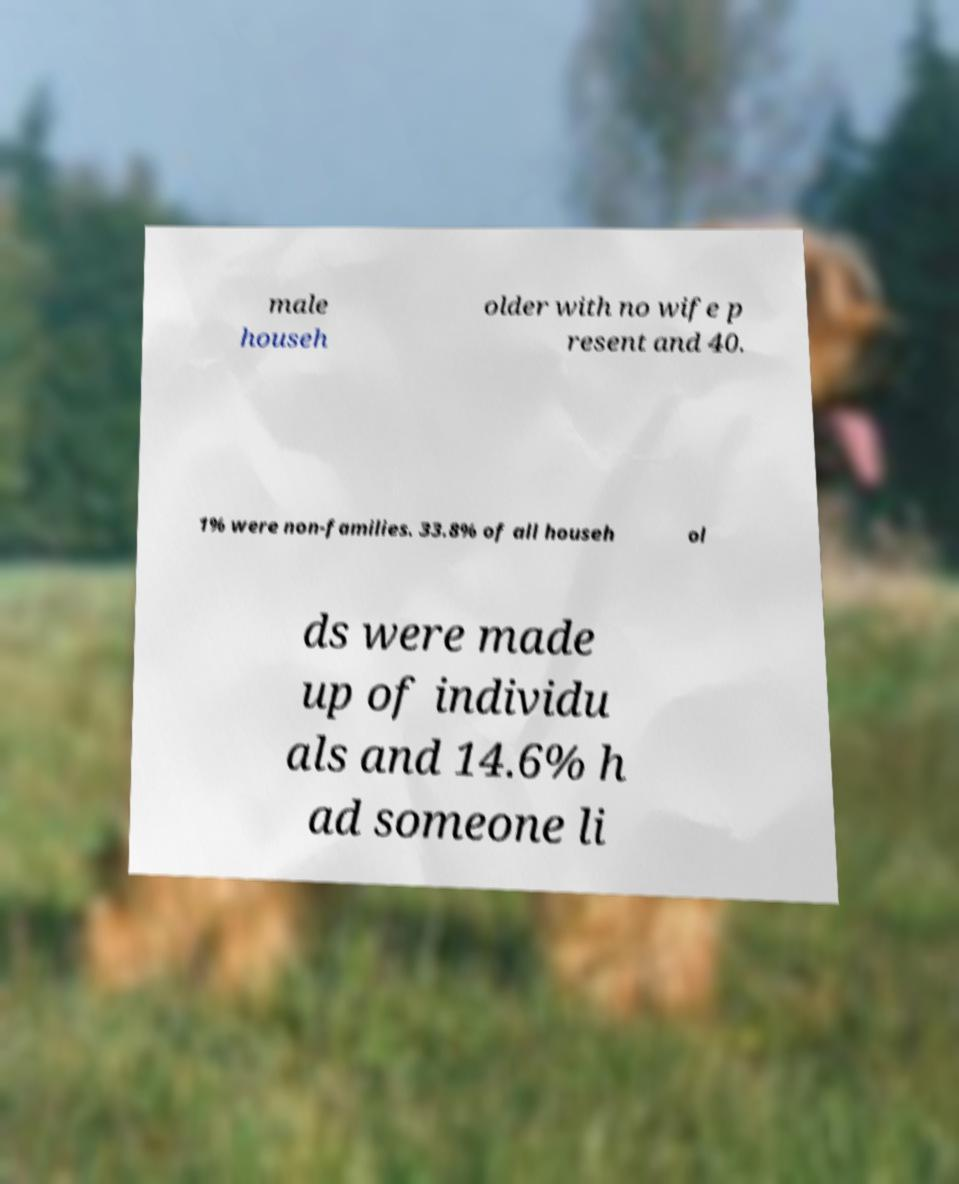Please read and relay the text visible in this image. What does it say? male househ older with no wife p resent and 40. 1% were non-families. 33.8% of all househ ol ds were made up of individu als and 14.6% h ad someone li 